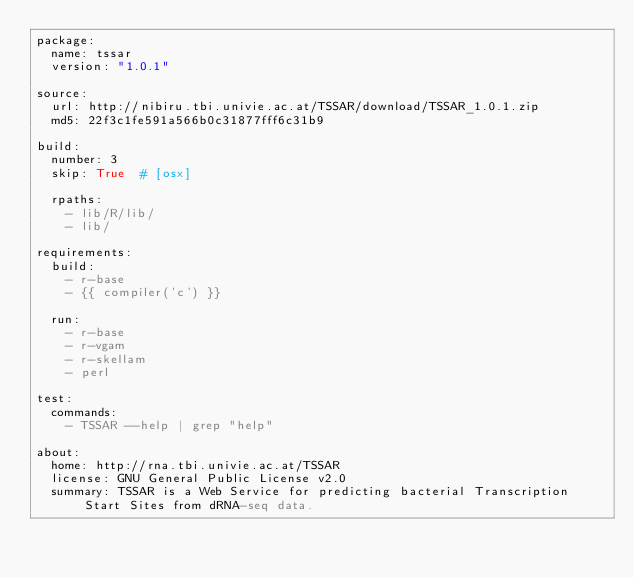<code> <loc_0><loc_0><loc_500><loc_500><_YAML_>package:
  name: tssar
  version: "1.0.1"

source:
  url: http://nibiru.tbi.univie.ac.at/TSSAR/download/TSSAR_1.0.1.zip
  md5: 22f3c1fe591a566b0c31877fff6c31b9

build:
  number: 3
  skip: True  # [osx]

  rpaths:
    - lib/R/lib/
    - lib/

requirements:
  build:
    - r-base
    - {{ compiler('c') }}

  run:
    - r-base
    - r-vgam
    - r-skellam
    - perl

test:
  commands:
    - TSSAR --help | grep "help"

about:
  home: http://rna.tbi.univie.ac.at/TSSAR
  license: GNU General Public License v2.0
  summary: TSSAR is a Web Service for predicting bacterial Transcription Start Sites from dRNA-seq data.
</code> 